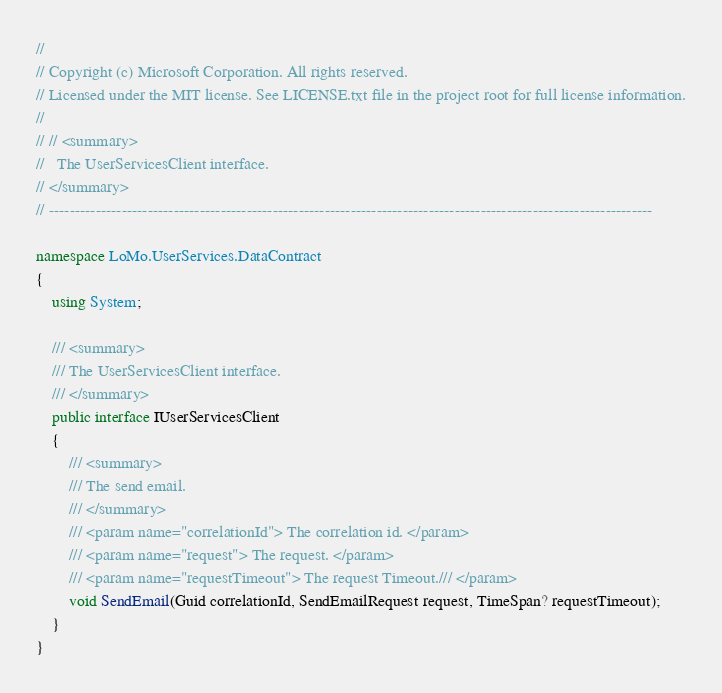Convert code to text. <code><loc_0><loc_0><loc_500><loc_500><_C#_>//
// Copyright (c) Microsoft Corporation. All rights reserved. 
// Licensed under the MIT license. See LICENSE.txt file in the project root for full license information.
//
// // <summary>
//   The UserServicesClient interface.
// </summary>
// --------------------------------------------------------------------------------------------------------------------

namespace LoMo.UserServices.DataContract
{
    using System;

    /// <summary>
    /// The UserServicesClient interface.
    /// </summary>
    public interface IUserServicesClient
    {
        /// <summary>
        /// The send email.
        /// </summary>
        /// <param name="correlationId"> The correlation id. </param>
        /// <param name="request"> The request. </param>
        /// <param name="requestTimeout"> The request Timeout./// </param>
        void SendEmail(Guid correlationId, SendEmailRequest request, TimeSpan? requestTimeout);
    }
}</code> 